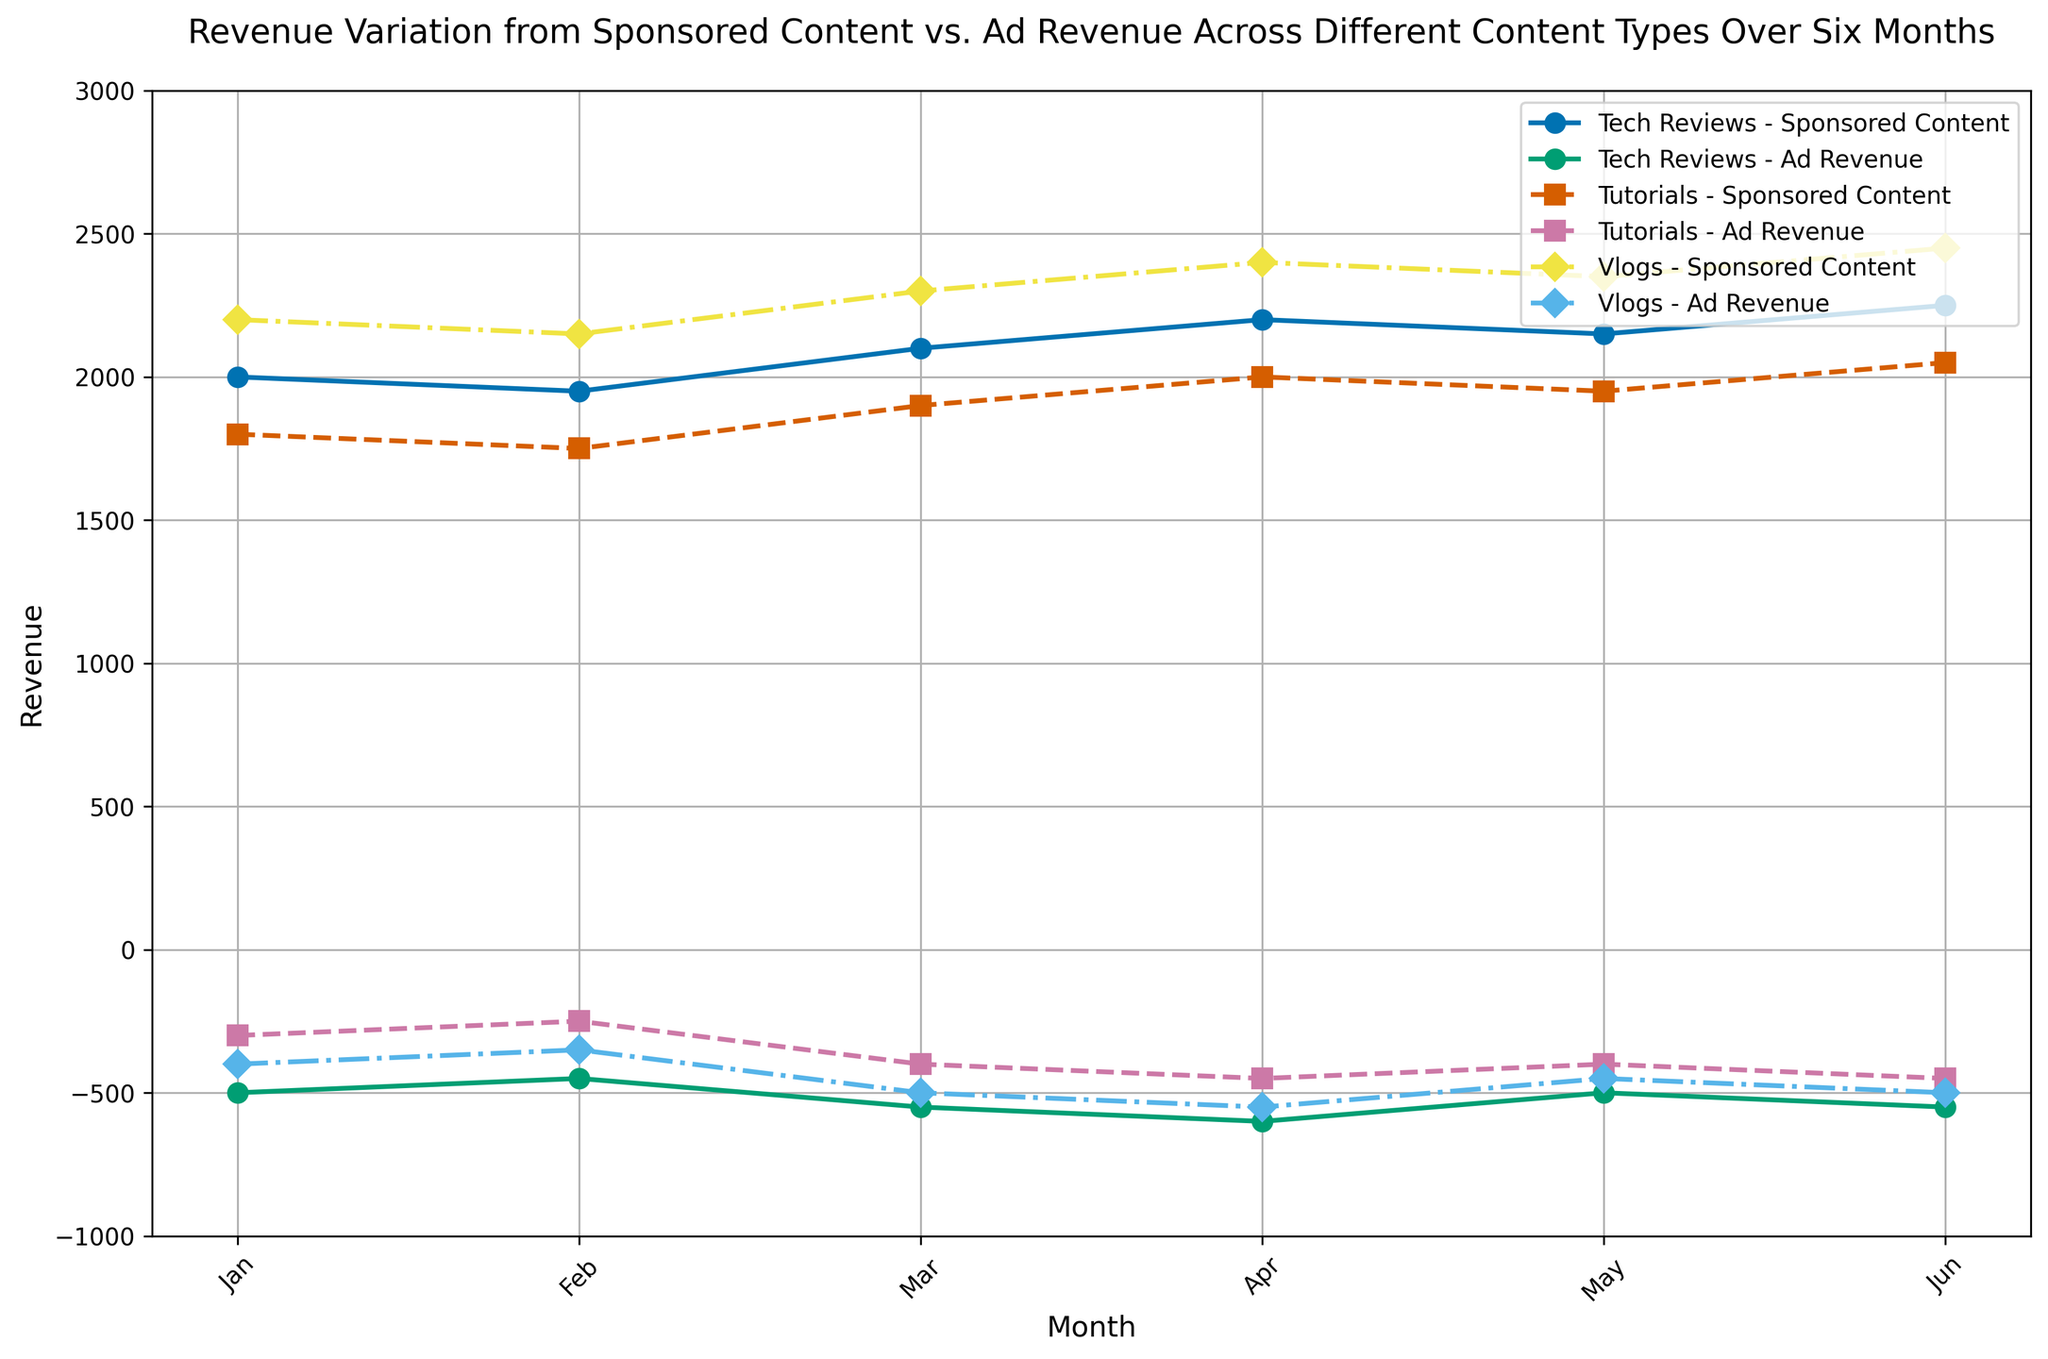What is the trend of revenue from Sponsored Content for Tech Reviews over six months? The revenue from Sponsored Content for Tech Reviews starts at 2000 in January, slightly decreases to 1950 in February, increases to 2100 in March, continues to rise to 2200 in April, then slightly goes down to 2150 in May, and finally increases again to 2250 in June.
Answer: The revenue trend for Tech Reviews from Sponsored Content shows a general increase with minor fluctuations How does the revenue from Ad Revenue for Vlogs change from January to June? In January, the Ad Revenue for Vlogs is -400. It decreases to -350 in February, further decreases to -500 by March, continues to -550 in April, improves slightly to -450 in May, and returns to -500 in June.
Answer: It varies, starting at -400 and ending at -500 with some fluctuations Which content type has the highest Sponsored Content revenue in March? By examining the chart for March, Sponsored Content revenue, Vlogs have the highest revenue at 2300, compared to Tech Reviews at 2100 and Tutorials at 1900.
Answer: Vlogs What is the average sponsored content revenue for Tutorials over the six months? Sum the values from January to June for Tutorials (1800, 1750, 1900, 2000, 1950, 2050) which equals 11450. Divide by the number of months (6) to get the average: 11450/6.
Answer: 1908.33 Which month has the largest difference between Sponsored Content and Ad Revenue for Tech Reviews? Calculate the difference for each month: January (2000 - (-500) = 2500), February (1950 - (-450) = 2400), March (2100 - (-550) = 2650), April (2200 - (-600) = 2800), May (2150 - (-500) = 2650), June (2250 - (-550) = 2800). The largest difference is in April and June, both at 2800.
Answer: April and June From the graph, can we infer if any content type has consistently positive Ad Revenue? All lines representing Ad Revenue for Tech Reviews, Tutorials, and Vlogs remain negative throughout the six-month period, indicating that none of the content types have consistently positive Ad Revenue.
Answer: No, all Ad Revenues are negative Compare the revenue trends of Sponsored Content and Ad Revenue for Tutorials. For Sponsored Content, the trend is mainly upward with a small dip in February and May, starting at 1800 in January and ending at 2050 in June. For Ad Revenue, it is consistently negative, starting at -300 and ending at -450.
Answer: Sponsored Content trend is upward, while Ad Revenue is consistently negative What is the net revenue (Sponsored Content + Ad Revenue) for Vlogs in May? For Vlogs in May, Sponsored Content revenue is 2350, and Ad Revenue is -450. The net revenue is calculated as 2350 + (-450).
Answer: 1900 Which content type has the least volatile Sponsored Content revenue over the six months? Explain briefly. By comparing the variation in values, Tutorials show the least volatility in Sponsored Content revenue, with values ranging from 1750 to 2050. Tech Reviews and Vlogs have higher fluctuations within their respective ranges.
Answer: Tutorials In which month does Tutorials have the smallest gap between Sponsored Content and Ad Revenue? Calculate the difference for each month for Tutorials: January (1800 - (-300) = 2100), February (1750 - (-250) = 2000), March (1900 - (-400) = 2300), April (2000 - (-450) = 2450), May (1950 - (-400) = 2350), June (2050 - (-450) = 2500). The smallest difference is in February, with a gap of 2000.
Answer: February 